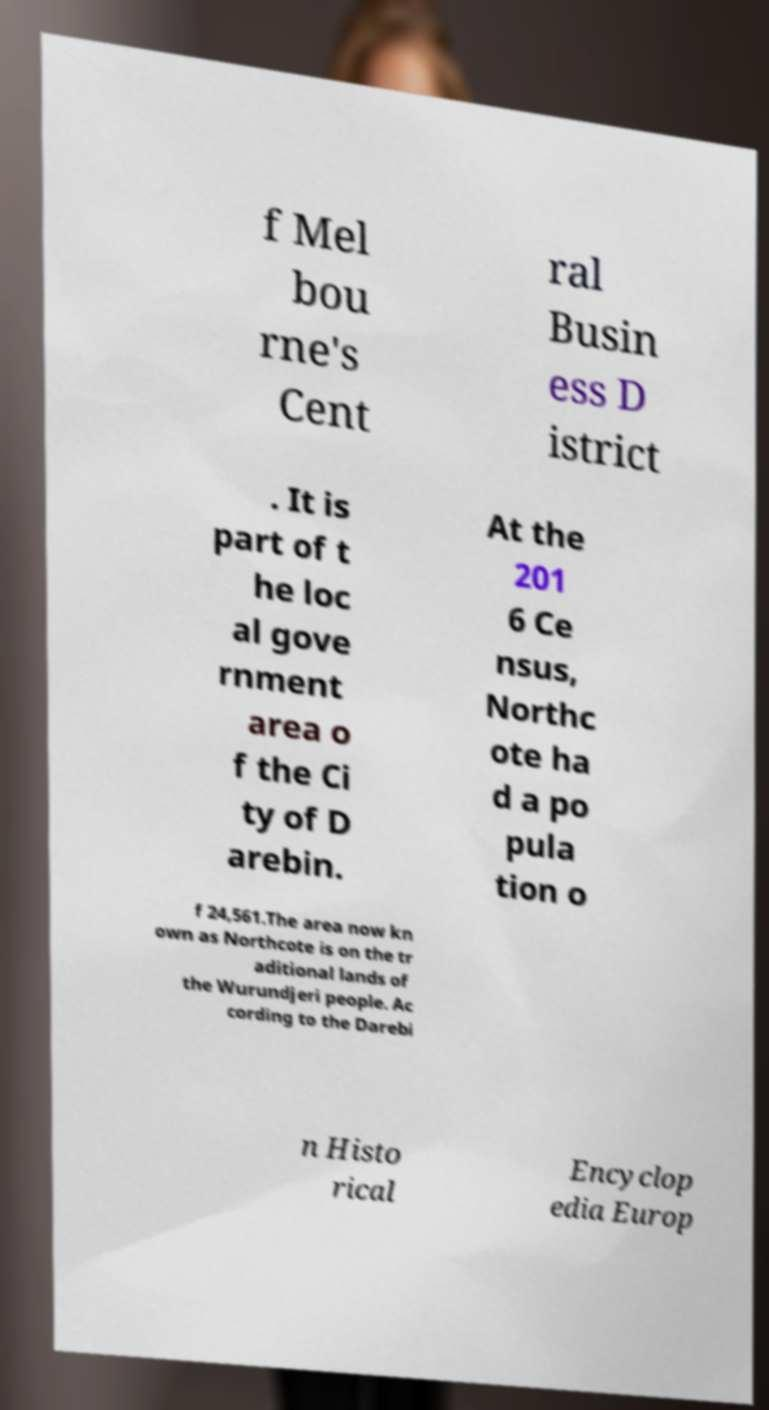What messages or text are displayed in this image? I need them in a readable, typed format. f Mel bou rne's Cent ral Busin ess D istrict . It is part of t he loc al gove rnment area o f the Ci ty of D arebin. At the 201 6 Ce nsus, Northc ote ha d a po pula tion o f 24,561.The area now kn own as Northcote is on the tr aditional lands of the Wurundjeri people. Ac cording to the Darebi n Histo rical Encyclop edia Europ 